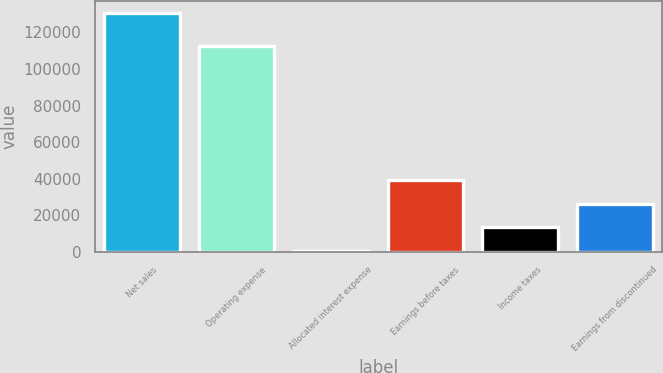Convert chart. <chart><loc_0><loc_0><loc_500><loc_500><bar_chart><fcel>Net sales<fcel>Operating expense<fcel>Allocated interest expense<fcel>Earnings before taxes<fcel>Income taxes<fcel>Earnings from discontinued<nl><fcel>130348<fcel>112565<fcel>454<fcel>39422.2<fcel>13443.4<fcel>26432.8<nl></chart> 